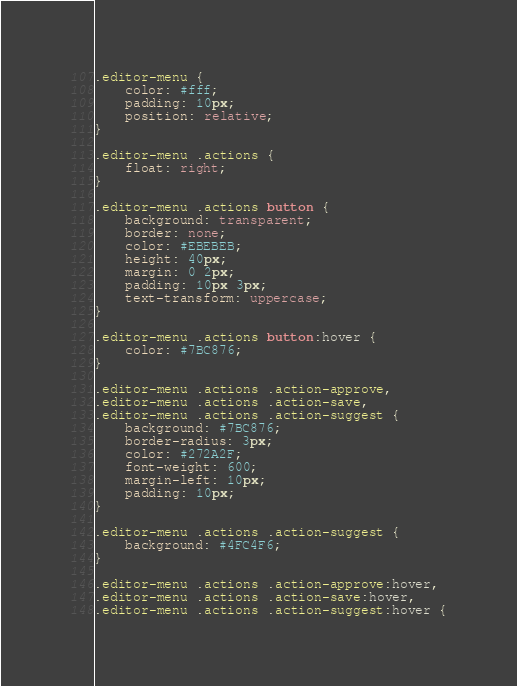Convert code to text. <code><loc_0><loc_0><loc_500><loc_500><_CSS_>.editor-menu {
    color: #fff;
    padding: 10px;
    position: relative;
}

.editor-menu .actions {
    float: right;
}

.editor-menu .actions button {
    background: transparent;
    border: none;
    color: #EBEBEB;
    height: 40px;
    margin: 0 2px;
    padding: 10px 3px;
    text-transform: uppercase;
}

.editor-menu .actions button:hover {
    color: #7BC876;
}

.editor-menu .actions .action-approve,
.editor-menu .actions .action-save,
.editor-menu .actions .action-suggest {
    background: #7BC876;
    border-radius: 3px;
    color: #272A2F;
    font-weight: 600;
    margin-left: 10px;
    padding: 10px;
}

.editor-menu .actions .action-suggest {
    background: #4FC4F6;
}

.editor-menu .actions .action-approve:hover,
.editor-menu .actions .action-save:hover,
.editor-menu .actions .action-suggest:hover {</code> 